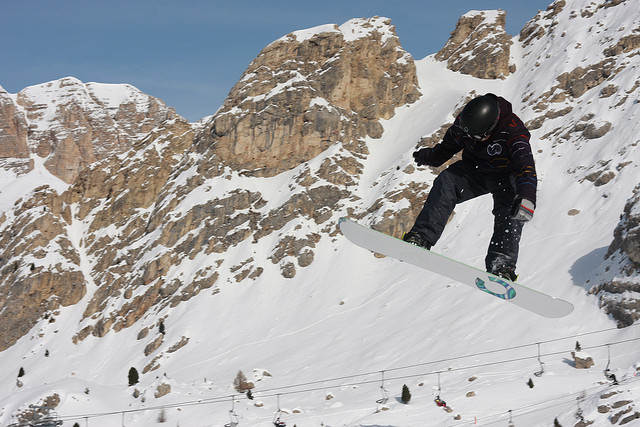Is the person wearing any protective gear? Yes, the person is equipped with essential protective gear, including a helmet and goggles. This gear is crucial for safety while engaging in high-speed snowboarding activities. 